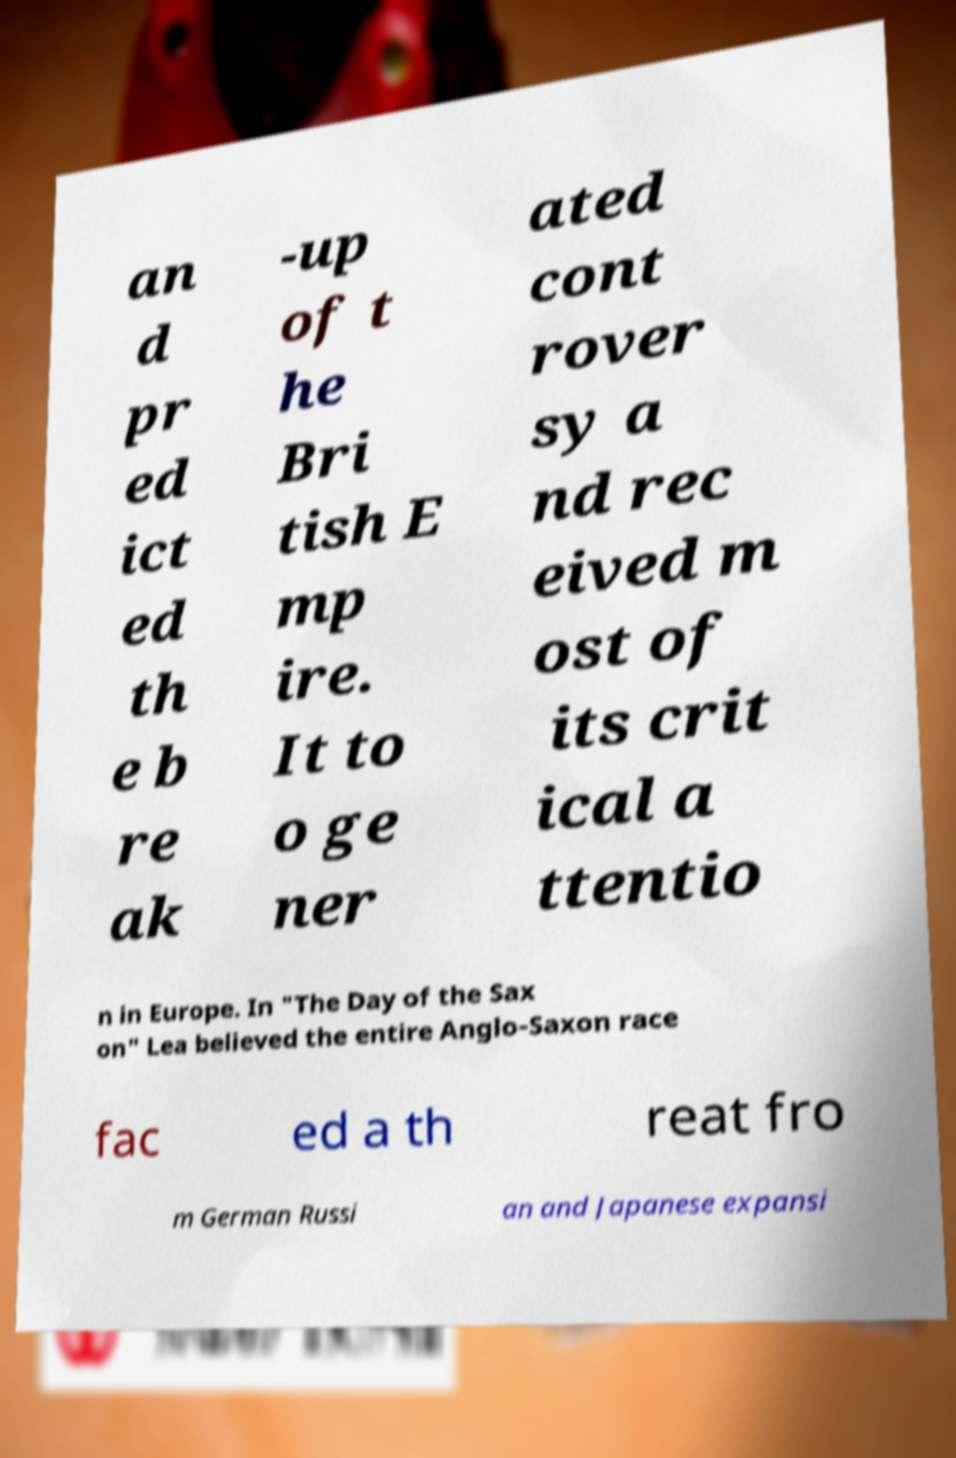Could you extract and type out the text from this image? an d pr ed ict ed th e b re ak -up of t he Bri tish E mp ire. It to o ge ner ated cont rover sy a nd rec eived m ost of its crit ical a ttentio n in Europe. In "The Day of the Sax on" Lea believed the entire Anglo-Saxon race fac ed a th reat fro m German Russi an and Japanese expansi 